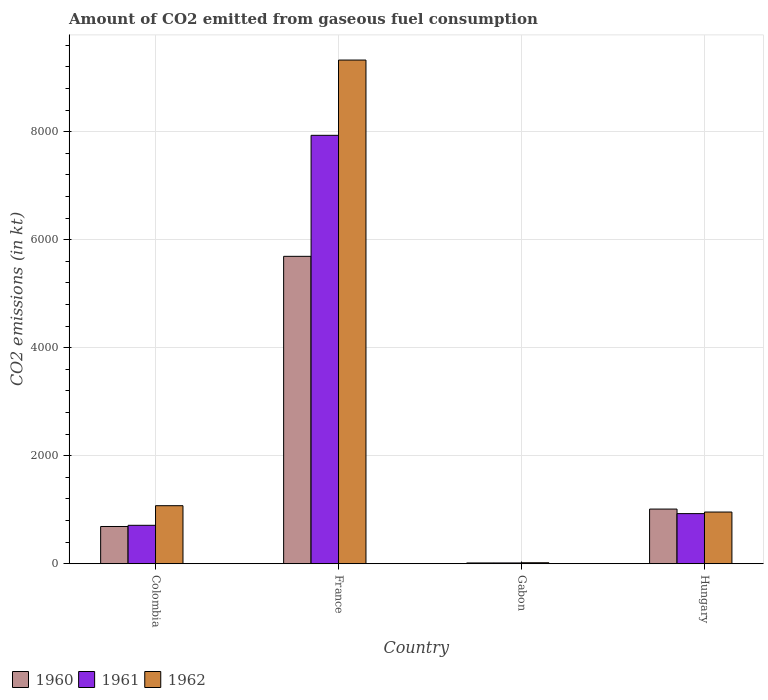How many groups of bars are there?
Keep it short and to the point. 4. Are the number of bars on each tick of the X-axis equal?
Your answer should be compact. Yes. How many bars are there on the 1st tick from the left?
Ensure brevity in your answer.  3. What is the label of the 1st group of bars from the left?
Your answer should be compact. Colombia. What is the amount of CO2 emitted in 1960 in Colombia?
Ensure brevity in your answer.  689.4. Across all countries, what is the maximum amount of CO2 emitted in 1961?
Provide a succinct answer. 7931.72. Across all countries, what is the minimum amount of CO2 emitted in 1961?
Give a very brief answer. 14.67. In which country was the amount of CO2 emitted in 1960 minimum?
Your answer should be very brief. Gabon. What is the total amount of CO2 emitted in 1960 in the graph?
Ensure brevity in your answer.  7407.34. What is the difference between the amount of CO2 emitted in 1960 in Colombia and that in Hungary?
Your answer should be compact. -322.7. What is the difference between the amount of CO2 emitted in 1960 in Hungary and the amount of CO2 emitted in 1962 in France?
Give a very brief answer. -8313.09. What is the average amount of CO2 emitted in 1960 per country?
Make the answer very short. 1851.83. What is the difference between the amount of CO2 emitted of/in 1960 and amount of CO2 emitted of/in 1961 in Hungary?
Make the answer very short. 84.34. What is the ratio of the amount of CO2 emitted in 1962 in Colombia to that in France?
Your answer should be compact. 0.12. Is the amount of CO2 emitted in 1962 in France less than that in Hungary?
Your response must be concise. No. What is the difference between the highest and the second highest amount of CO2 emitted in 1962?
Give a very brief answer. -8250.75. What is the difference between the highest and the lowest amount of CO2 emitted in 1960?
Make the answer very short. 5676.52. In how many countries, is the amount of CO2 emitted in 1961 greater than the average amount of CO2 emitted in 1961 taken over all countries?
Give a very brief answer. 1. What does the 1st bar from the right in Colombia represents?
Provide a short and direct response. 1962. Is it the case that in every country, the sum of the amount of CO2 emitted in 1960 and amount of CO2 emitted in 1961 is greater than the amount of CO2 emitted in 1962?
Your answer should be very brief. Yes. Are the values on the major ticks of Y-axis written in scientific E-notation?
Keep it short and to the point. No. Does the graph contain any zero values?
Your answer should be very brief. No. How many legend labels are there?
Offer a very short reply. 3. How are the legend labels stacked?
Provide a succinct answer. Horizontal. What is the title of the graph?
Give a very brief answer. Amount of CO2 emitted from gaseous fuel consumption. What is the label or title of the X-axis?
Make the answer very short. Country. What is the label or title of the Y-axis?
Give a very brief answer. CO2 emissions (in kt). What is the CO2 emissions (in kt) in 1960 in Colombia?
Make the answer very short. 689.4. What is the CO2 emissions (in kt) in 1961 in Colombia?
Ensure brevity in your answer.  711.4. What is the CO2 emissions (in kt) in 1962 in Colombia?
Keep it short and to the point. 1074.43. What is the CO2 emissions (in kt) in 1960 in France?
Provide a short and direct response. 5691.18. What is the CO2 emissions (in kt) in 1961 in France?
Give a very brief answer. 7931.72. What is the CO2 emissions (in kt) of 1962 in France?
Keep it short and to the point. 9325.18. What is the CO2 emissions (in kt) of 1960 in Gabon?
Your answer should be very brief. 14.67. What is the CO2 emissions (in kt) of 1961 in Gabon?
Offer a very short reply. 14.67. What is the CO2 emissions (in kt) of 1962 in Gabon?
Your answer should be very brief. 18.34. What is the CO2 emissions (in kt) of 1960 in Hungary?
Your answer should be very brief. 1012.09. What is the CO2 emissions (in kt) of 1961 in Hungary?
Your response must be concise. 927.75. What is the CO2 emissions (in kt) in 1962 in Hungary?
Make the answer very short. 957.09. Across all countries, what is the maximum CO2 emissions (in kt) of 1960?
Provide a short and direct response. 5691.18. Across all countries, what is the maximum CO2 emissions (in kt) of 1961?
Keep it short and to the point. 7931.72. Across all countries, what is the maximum CO2 emissions (in kt) in 1962?
Your answer should be compact. 9325.18. Across all countries, what is the minimum CO2 emissions (in kt) of 1960?
Your response must be concise. 14.67. Across all countries, what is the minimum CO2 emissions (in kt) in 1961?
Keep it short and to the point. 14.67. Across all countries, what is the minimum CO2 emissions (in kt) in 1962?
Provide a succinct answer. 18.34. What is the total CO2 emissions (in kt) of 1960 in the graph?
Your answer should be very brief. 7407.34. What is the total CO2 emissions (in kt) of 1961 in the graph?
Your response must be concise. 9585.54. What is the total CO2 emissions (in kt) of 1962 in the graph?
Ensure brevity in your answer.  1.14e+04. What is the difference between the CO2 emissions (in kt) in 1960 in Colombia and that in France?
Offer a terse response. -5001.79. What is the difference between the CO2 emissions (in kt) in 1961 in Colombia and that in France?
Your answer should be compact. -7220.32. What is the difference between the CO2 emissions (in kt) in 1962 in Colombia and that in France?
Make the answer very short. -8250.75. What is the difference between the CO2 emissions (in kt) in 1960 in Colombia and that in Gabon?
Provide a succinct answer. 674.73. What is the difference between the CO2 emissions (in kt) of 1961 in Colombia and that in Gabon?
Give a very brief answer. 696.73. What is the difference between the CO2 emissions (in kt) in 1962 in Colombia and that in Gabon?
Ensure brevity in your answer.  1056.1. What is the difference between the CO2 emissions (in kt) in 1960 in Colombia and that in Hungary?
Keep it short and to the point. -322.7. What is the difference between the CO2 emissions (in kt) of 1961 in Colombia and that in Hungary?
Keep it short and to the point. -216.35. What is the difference between the CO2 emissions (in kt) of 1962 in Colombia and that in Hungary?
Provide a succinct answer. 117.34. What is the difference between the CO2 emissions (in kt) of 1960 in France and that in Gabon?
Offer a terse response. 5676.52. What is the difference between the CO2 emissions (in kt) of 1961 in France and that in Gabon?
Offer a terse response. 7917.05. What is the difference between the CO2 emissions (in kt) in 1962 in France and that in Gabon?
Provide a succinct answer. 9306.85. What is the difference between the CO2 emissions (in kt) of 1960 in France and that in Hungary?
Your answer should be compact. 4679.09. What is the difference between the CO2 emissions (in kt) of 1961 in France and that in Hungary?
Make the answer very short. 7003.97. What is the difference between the CO2 emissions (in kt) in 1962 in France and that in Hungary?
Give a very brief answer. 8368.09. What is the difference between the CO2 emissions (in kt) in 1960 in Gabon and that in Hungary?
Provide a succinct answer. -997.42. What is the difference between the CO2 emissions (in kt) in 1961 in Gabon and that in Hungary?
Keep it short and to the point. -913.08. What is the difference between the CO2 emissions (in kt) of 1962 in Gabon and that in Hungary?
Offer a terse response. -938.75. What is the difference between the CO2 emissions (in kt) in 1960 in Colombia and the CO2 emissions (in kt) in 1961 in France?
Your answer should be very brief. -7242.32. What is the difference between the CO2 emissions (in kt) of 1960 in Colombia and the CO2 emissions (in kt) of 1962 in France?
Your answer should be compact. -8635.78. What is the difference between the CO2 emissions (in kt) of 1961 in Colombia and the CO2 emissions (in kt) of 1962 in France?
Keep it short and to the point. -8613.78. What is the difference between the CO2 emissions (in kt) of 1960 in Colombia and the CO2 emissions (in kt) of 1961 in Gabon?
Keep it short and to the point. 674.73. What is the difference between the CO2 emissions (in kt) in 1960 in Colombia and the CO2 emissions (in kt) in 1962 in Gabon?
Your answer should be compact. 671.06. What is the difference between the CO2 emissions (in kt) of 1961 in Colombia and the CO2 emissions (in kt) of 1962 in Gabon?
Offer a terse response. 693.06. What is the difference between the CO2 emissions (in kt) of 1960 in Colombia and the CO2 emissions (in kt) of 1961 in Hungary?
Your answer should be very brief. -238.35. What is the difference between the CO2 emissions (in kt) in 1960 in Colombia and the CO2 emissions (in kt) in 1962 in Hungary?
Your answer should be compact. -267.69. What is the difference between the CO2 emissions (in kt) of 1961 in Colombia and the CO2 emissions (in kt) of 1962 in Hungary?
Provide a succinct answer. -245.69. What is the difference between the CO2 emissions (in kt) in 1960 in France and the CO2 emissions (in kt) in 1961 in Gabon?
Provide a succinct answer. 5676.52. What is the difference between the CO2 emissions (in kt) of 1960 in France and the CO2 emissions (in kt) of 1962 in Gabon?
Your response must be concise. 5672.85. What is the difference between the CO2 emissions (in kt) in 1961 in France and the CO2 emissions (in kt) in 1962 in Gabon?
Offer a very short reply. 7913.39. What is the difference between the CO2 emissions (in kt) of 1960 in France and the CO2 emissions (in kt) of 1961 in Hungary?
Your answer should be very brief. 4763.43. What is the difference between the CO2 emissions (in kt) in 1960 in France and the CO2 emissions (in kt) in 1962 in Hungary?
Make the answer very short. 4734.1. What is the difference between the CO2 emissions (in kt) in 1961 in France and the CO2 emissions (in kt) in 1962 in Hungary?
Make the answer very short. 6974.63. What is the difference between the CO2 emissions (in kt) of 1960 in Gabon and the CO2 emissions (in kt) of 1961 in Hungary?
Make the answer very short. -913.08. What is the difference between the CO2 emissions (in kt) in 1960 in Gabon and the CO2 emissions (in kt) in 1962 in Hungary?
Offer a terse response. -942.42. What is the difference between the CO2 emissions (in kt) in 1961 in Gabon and the CO2 emissions (in kt) in 1962 in Hungary?
Ensure brevity in your answer.  -942.42. What is the average CO2 emissions (in kt) in 1960 per country?
Keep it short and to the point. 1851.84. What is the average CO2 emissions (in kt) of 1961 per country?
Your answer should be very brief. 2396.38. What is the average CO2 emissions (in kt) of 1962 per country?
Provide a succinct answer. 2843.76. What is the difference between the CO2 emissions (in kt) in 1960 and CO2 emissions (in kt) in 1961 in Colombia?
Ensure brevity in your answer.  -22. What is the difference between the CO2 emissions (in kt) in 1960 and CO2 emissions (in kt) in 1962 in Colombia?
Offer a very short reply. -385.04. What is the difference between the CO2 emissions (in kt) in 1961 and CO2 emissions (in kt) in 1962 in Colombia?
Your response must be concise. -363.03. What is the difference between the CO2 emissions (in kt) of 1960 and CO2 emissions (in kt) of 1961 in France?
Your response must be concise. -2240.54. What is the difference between the CO2 emissions (in kt) in 1960 and CO2 emissions (in kt) in 1962 in France?
Ensure brevity in your answer.  -3634. What is the difference between the CO2 emissions (in kt) in 1961 and CO2 emissions (in kt) in 1962 in France?
Make the answer very short. -1393.46. What is the difference between the CO2 emissions (in kt) in 1960 and CO2 emissions (in kt) in 1962 in Gabon?
Give a very brief answer. -3.67. What is the difference between the CO2 emissions (in kt) in 1961 and CO2 emissions (in kt) in 1962 in Gabon?
Give a very brief answer. -3.67. What is the difference between the CO2 emissions (in kt) in 1960 and CO2 emissions (in kt) in 1961 in Hungary?
Provide a succinct answer. 84.34. What is the difference between the CO2 emissions (in kt) of 1960 and CO2 emissions (in kt) of 1962 in Hungary?
Provide a succinct answer. 55.01. What is the difference between the CO2 emissions (in kt) in 1961 and CO2 emissions (in kt) in 1962 in Hungary?
Provide a short and direct response. -29.34. What is the ratio of the CO2 emissions (in kt) in 1960 in Colombia to that in France?
Provide a short and direct response. 0.12. What is the ratio of the CO2 emissions (in kt) of 1961 in Colombia to that in France?
Offer a very short reply. 0.09. What is the ratio of the CO2 emissions (in kt) of 1962 in Colombia to that in France?
Your answer should be compact. 0.12. What is the ratio of the CO2 emissions (in kt) of 1960 in Colombia to that in Gabon?
Give a very brief answer. 47. What is the ratio of the CO2 emissions (in kt) of 1961 in Colombia to that in Gabon?
Give a very brief answer. 48.5. What is the ratio of the CO2 emissions (in kt) in 1962 in Colombia to that in Gabon?
Your answer should be very brief. 58.6. What is the ratio of the CO2 emissions (in kt) of 1960 in Colombia to that in Hungary?
Give a very brief answer. 0.68. What is the ratio of the CO2 emissions (in kt) of 1961 in Colombia to that in Hungary?
Your answer should be very brief. 0.77. What is the ratio of the CO2 emissions (in kt) in 1962 in Colombia to that in Hungary?
Your response must be concise. 1.12. What is the ratio of the CO2 emissions (in kt) in 1960 in France to that in Gabon?
Your answer should be compact. 388. What is the ratio of the CO2 emissions (in kt) in 1961 in France to that in Gabon?
Your answer should be compact. 540.75. What is the ratio of the CO2 emissions (in kt) of 1962 in France to that in Gabon?
Your response must be concise. 508.6. What is the ratio of the CO2 emissions (in kt) of 1960 in France to that in Hungary?
Offer a very short reply. 5.62. What is the ratio of the CO2 emissions (in kt) of 1961 in France to that in Hungary?
Provide a succinct answer. 8.55. What is the ratio of the CO2 emissions (in kt) in 1962 in France to that in Hungary?
Offer a very short reply. 9.74. What is the ratio of the CO2 emissions (in kt) in 1960 in Gabon to that in Hungary?
Your answer should be very brief. 0.01. What is the ratio of the CO2 emissions (in kt) in 1961 in Gabon to that in Hungary?
Offer a very short reply. 0.02. What is the ratio of the CO2 emissions (in kt) in 1962 in Gabon to that in Hungary?
Provide a succinct answer. 0.02. What is the difference between the highest and the second highest CO2 emissions (in kt) in 1960?
Your response must be concise. 4679.09. What is the difference between the highest and the second highest CO2 emissions (in kt) of 1961?
Offer a very short reply. 7003.97. What is the difference between the highest and the second highest CO2 emissions (in kt) in 1962?
Your answer should be very brief. 8250.75. What is the difference between the highest and the lowest CO2 emissions (in kt) of 1960?
Provide a short and direct response. 5676.52. What is the difference between the highest and the lowest CO2 emissions (in kt) in 1961?
Your response must be concise. 7917.05. What is the difference between the highest and the lowest CO2 emissions (in kt) of 1962?
Keep it short and to the point. 9306.85. 